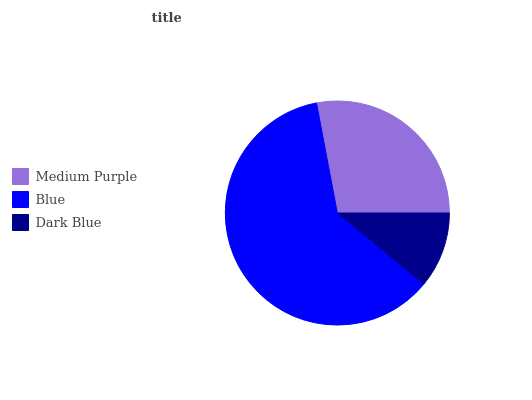Is Dark Blue the minimum?
Answer yes or no. Yes. Is Blue the maximum?
Answer yes or no. Yes. Is Blue the minimum?
Answer yes or no. No. Is Dark Blue the maximum?
Answer yes or no. No. Is Blue greater than Dark Blue?
Answer yes or no. Yes. Is Dark Blue less than Blue?
Answer yes or no. Yes. Is Dark Blue greater than Blue?
Answer yes or no. No. Is Blue less than Dark Blue?
Answer yes or no. No. Is Medium Purple the high median?
Answer yes or no. Yes. Is Medium Purple the low median?
Answer yes or no. Yes. Is Dark Blue the high median?
Answer yes or no. No. Is Dark Blue the low median?
Answer yes or no. No. 